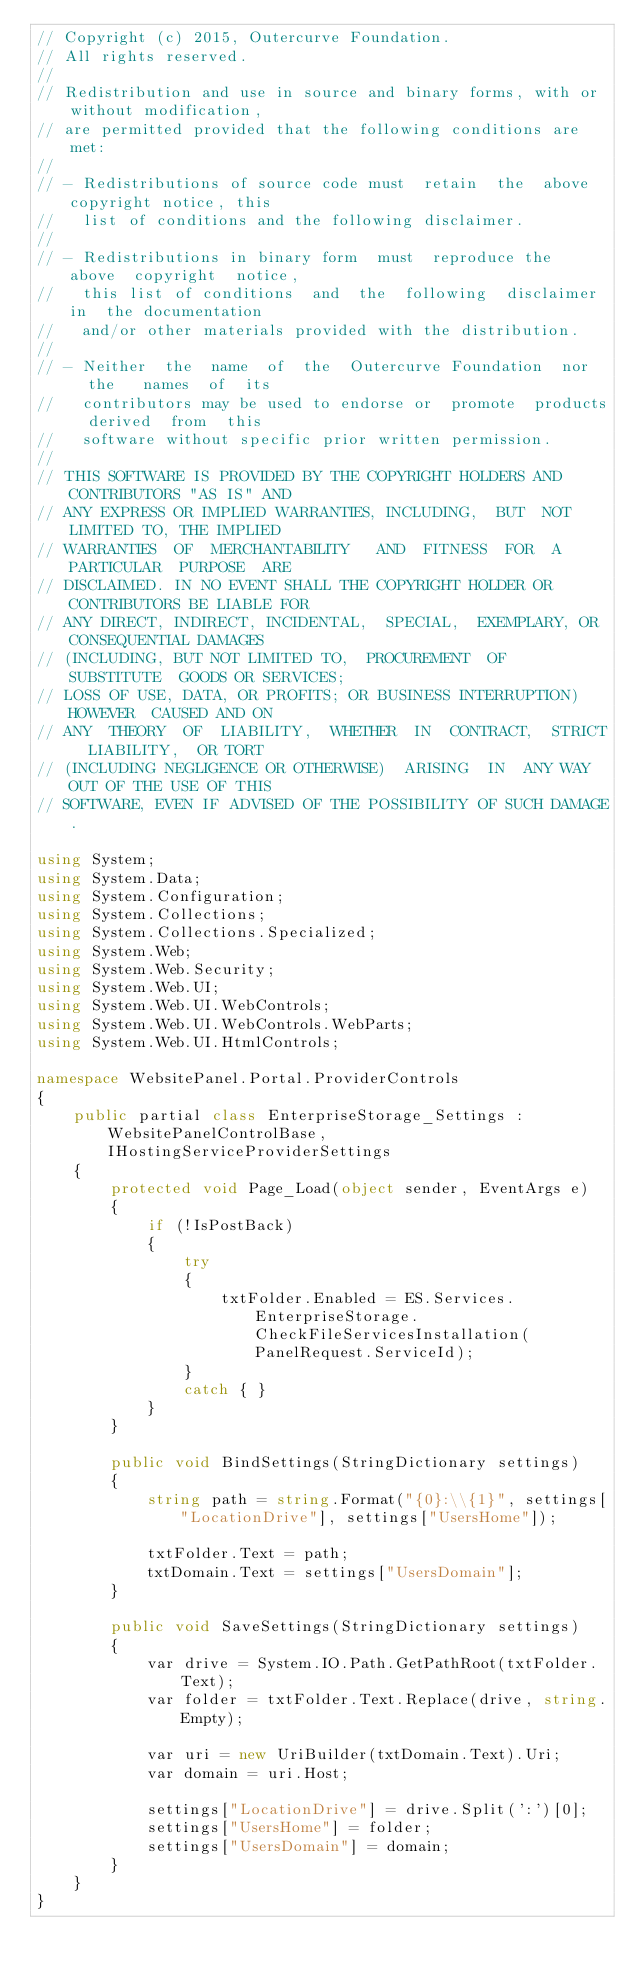Convert code to text. <code><loc_0><loc_0><loc_500><loc_500><_C#_>// Copyright (c) 2015, Outercurve Foundation.
// All rights reserved.
//
// Redistribution and use in source and binary forms, with or without modification,
// are permitted provided that the following conditions are met:
//
// - Redistributions of source code must  retain  the  above copyright notice, this
//   list of conditions and the following disclaimer.
//
// - Redistributions in binary form  must  reproduce the  above  copyright  notice,
//   this list of conditions  and  the  following  disclaimer in  the documentation
//   and/or other materials provided with the distribution.
//
// - Neither  the  name  of  the  Outercurve Foundation  nor   the   names  of  its
//   contributors may be used to endorse or  promote  products  derived  from  this
//   software without specific prior written permission.
//
// THIS SOFTWARE IS PROVIDED BY THE COPYRIGHT HOLDERS AND CONTRIBUTORS "AS IS" AND
// ANY EXPRESS OR IMPLIED WARRANTIES, INCLUDING,  BUT  NOT  LIMITED TO, THE IMPLIED
// WARRANTIES  OF  MERCHANTABILITY   AND  FITNESS  FOR  A  PARTICULAR  PURPOSE  ARE
// DISCLAIMED. IN NO EVENT SHALL THE COPYRIGHT HOLDER OR CONTRIBUTORS BE LIABLE FOR
// ANY DIRECT, INDIRECT, INCIDENTAL,  SPECIAL,  EXEMPLARY, OR CONSEQUENTIAL DAMAGES
// (INCLUDING, BUT NOT LIMITED TO,  PROCUREMENT  OF  SUBSTITUTE  GOODS OR SERVICES;
// LOSS OF USE, DATA, OR PROFITS; OR BUSINESS INTERRUPTION)  HOWEVER  CAUSED AND ON
// ANY  THEORY  OF  LIABILITY,  WHETHER  IN  CONTRACT,  STRICT  LIABILITY,  OR TORT
// (INCLUDING NEGLIGENCE OR OTHERWISE)  ARISING  IN  ANY WAY OUT OF THE USE OF THIS
// SOFTWARE, EVEN IF ADVISED OF THE POSSIBILITY OF SUCH DAMAGE.

using System;
using System.Data;
using System.Configuration;
using System.Collections;
using System.Collections.Specialized;
using System.Web;
using System.Web.Security;
using System.Web.UI;
using System.Web.UI.WebControls;
using System.Web.UI.WebControls.WebParts;
using System.Web.UI.HtmlControls;

namespace WebsitePanel.Portal.ProviderControls
{
    public partial class EnterpriseStorage_Settings : WebsitePanelControlBase, IHostingServiceProviderSettings
    {
        protected void Page_Load(object sender, EventArgs e)
        {
            if (!IsPostBack)
            {
                try
                {
                    txtFolder.Enabled = ES.Services.EnterpriseStorage.CheckFileServicesInstallation(PanelRequest.ServiceId);
                }
                catch { }
            }
        }

        public void BindSettings(StringDictionary settings)
        {
            string path = string.Format("{0}:\\{1}", settings["LocationDrive"], settings["UsersHome"]);

            txtFolder.Text = path;
            txtDomain.Text = settings["UsersDomain"];
        }

        public void SaveSettings(StringDictionary settings)
        {
            var drive = System.IO.Path.GetPathRoot(txtFolder.Text);
            var folder = txtFolder.Text.Replace(drive, string.Empty);

            var uri = new UriBuilder(txtDomain.Text).Uri;
            var domain = uri.Host;

            settings["LocationDrive"] = drive.Split(':')[0];
            settings["UsersHome"] = folder;
            settings["UsersDomain"] = domain;
        }
    }
}
</code> 